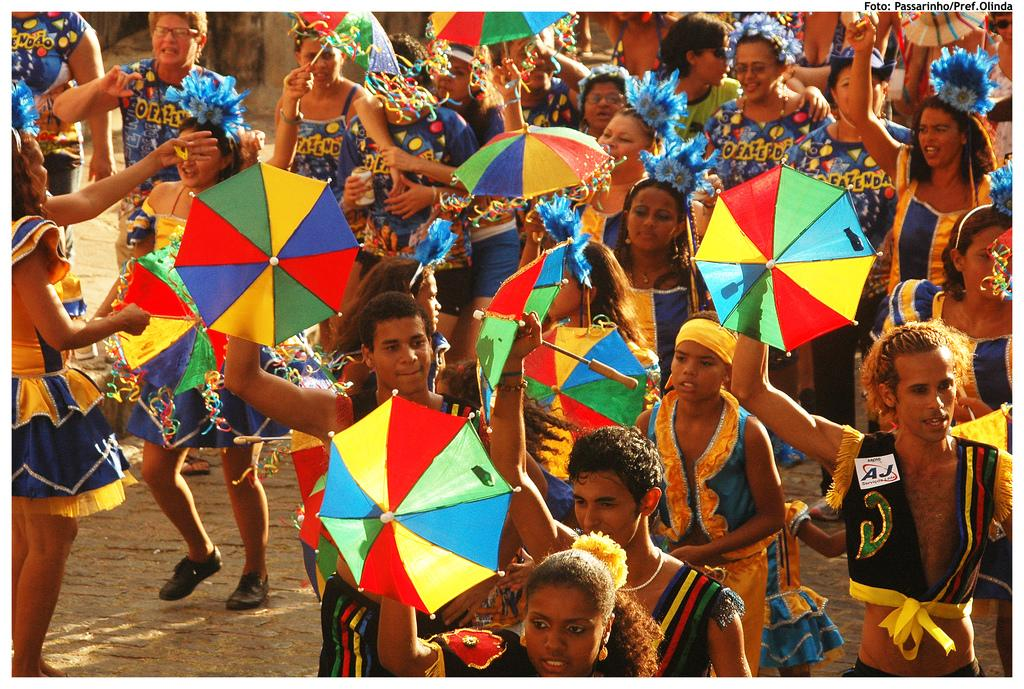<image>
Render a clear and concise summary of the photo. People holding mini umbrellas in a crowd with a man wearing a vest that says "AJ" on it. 